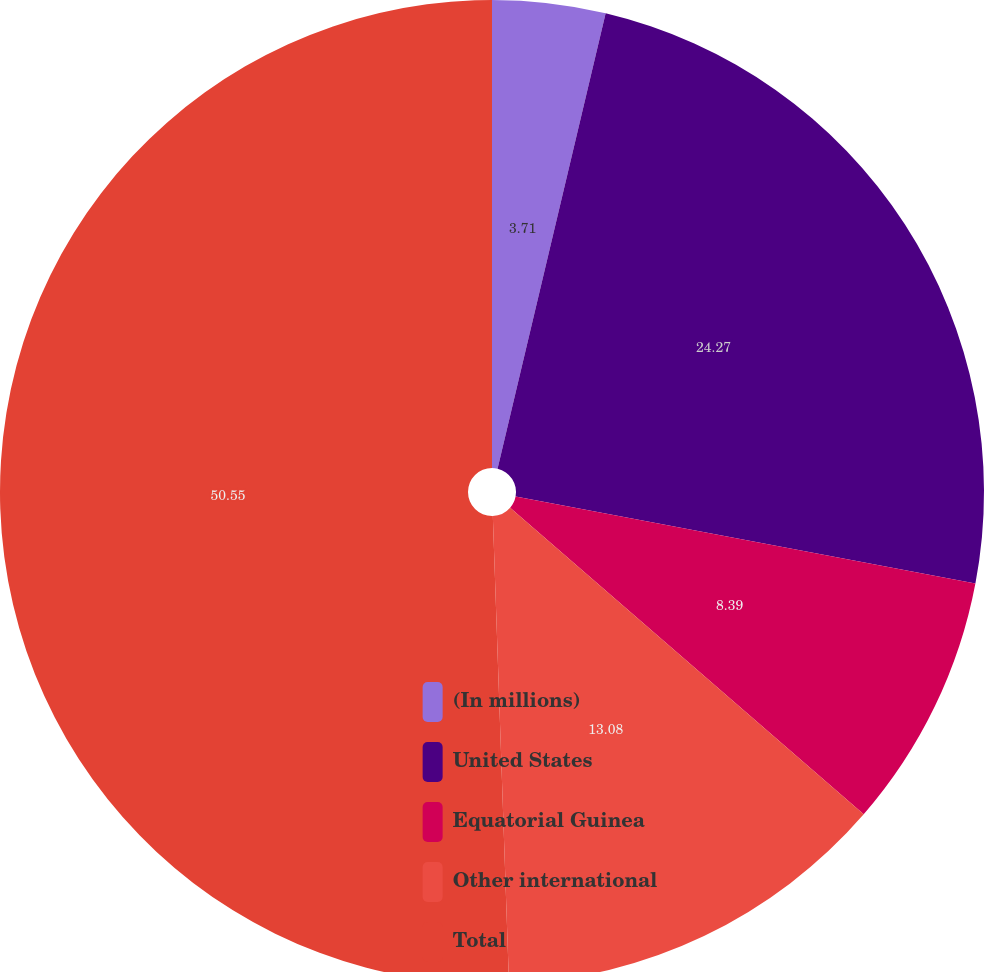<chart> <loc_0><loc_0><loc_500><loc_500><pie_chart><fcel>(In millions)<fcel>United States<fcel>Equatorial Guinea<fcel>Other international<fcel>Total<nl><fcel>3.71%<fcel>24.27%<fcel>8.39%<fcel>13.08%<fcel>50.55%<nl></chart> 